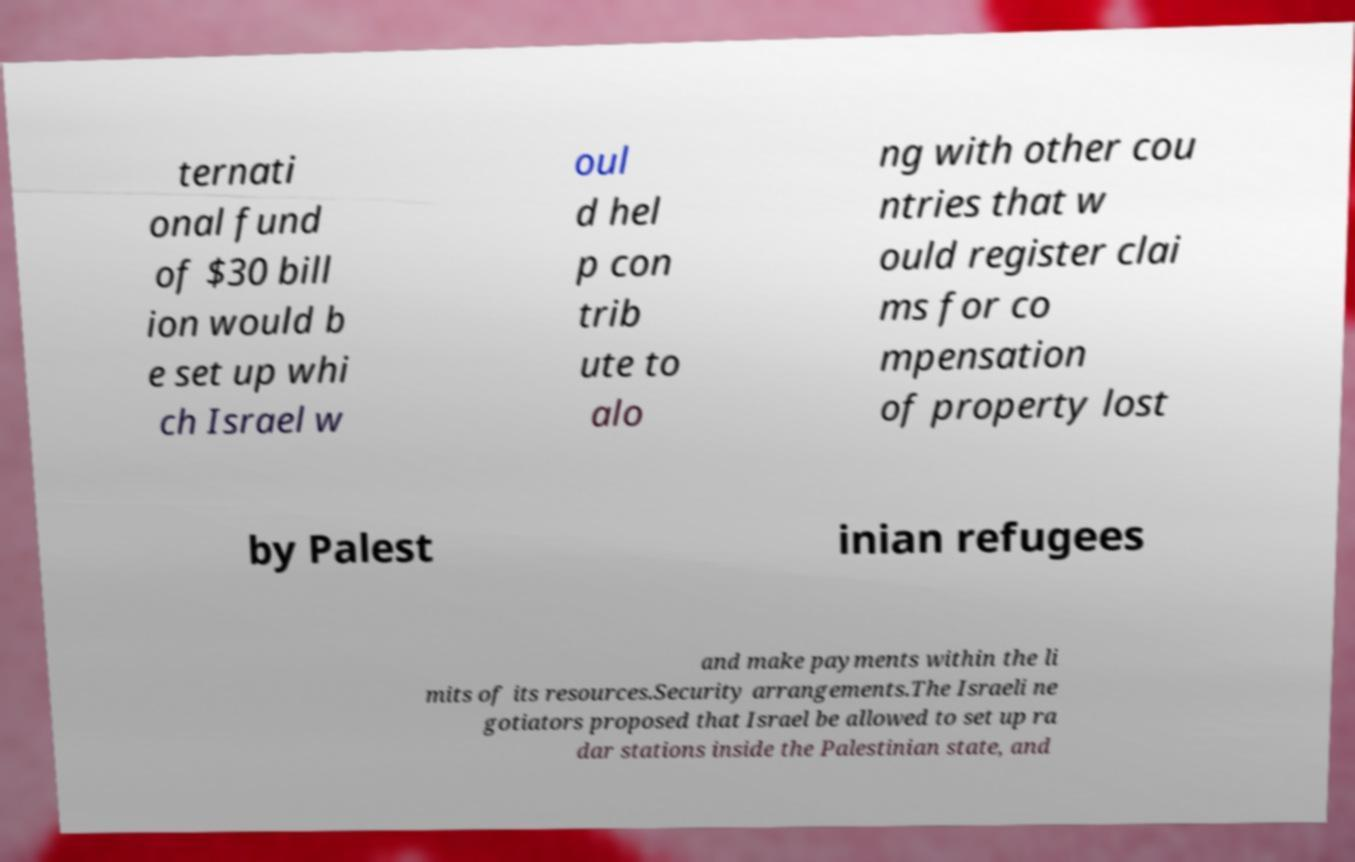There's text embedded in this image that I need extracted. Can you transcribe it verbatim? ternati onal fund of $30 bill ion would b e set up whi ch Israel w oul d hel p con trib ute to alo ng with other cou ntries that w ould register clai ms for co mpensation of property lost by Palest inian refugees and make payments within the li mits of its resources.Security arrangements.The Israeli ne gotiators proposed that Israel be allowed to set up ra dar stations inside the Palestinian state, and 